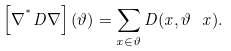Convert formula to latex. <formula><loc_0><loc_0><loc_500><loc_500>\left [ \nabla ^ { ^ { * } } D \nabla \right ] ( \vartheta ) = \sum _ { x \in \vartheta } D ( x , \vartheta \ x ) .</formula> 